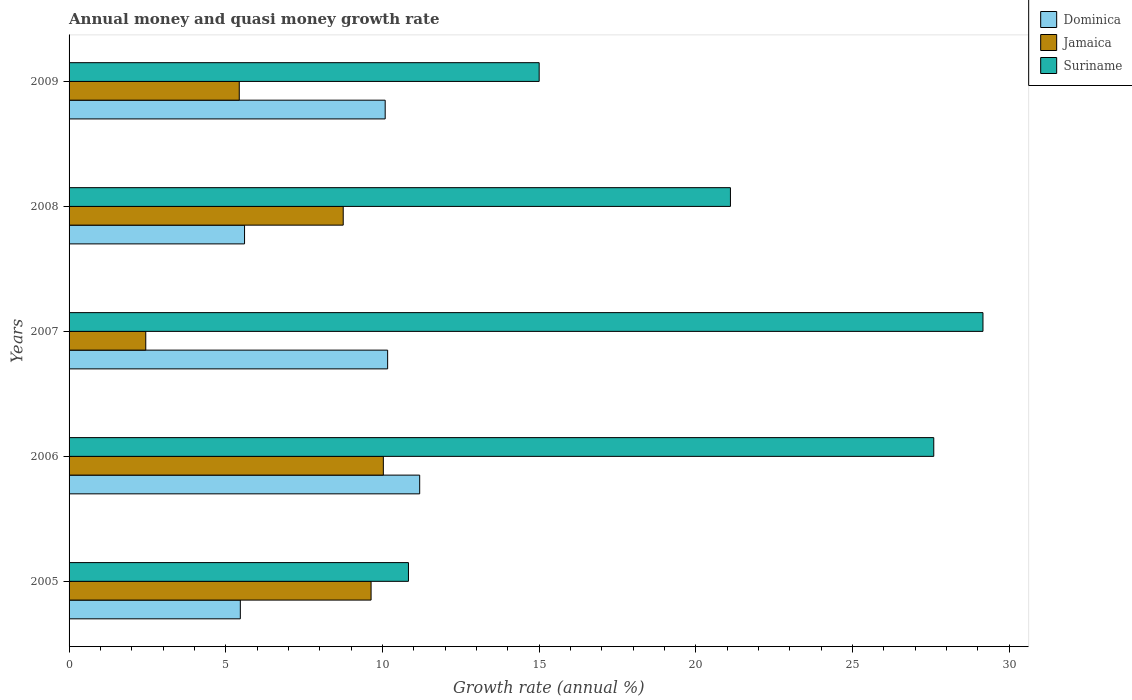How many bars are there on the 2nd tick from the bottom?
Offer a very short reply. 3. What is the growth rate in Dominica in 2008?
Ensure brevity in your answer.  5.6. Across all years, what is the maximum growth rate in Jamaica?
Make the answer very short. 10.03. Across all years, what is the minimum growth rate in Jamaica?
Offer a terse response. 2.45. In which year was the growth rate in Jamaica minimum?
Keep it short and to the point. 2007. What is the total growth rate in Jamaica in the graph?
Your response must be concise. 36.3. What is the difference between the growth rate in Dominica in 2007 and that in 2008?
Offer a terse response. 4.57. What is the difference between the growth rate in Jamaica in 2005 and the growth rate in Dominica in 2008?
Give a very brief answer. 4.04. What is the average growth rate in Jamaica per year?
Give a very brief answer. 7.26. In the year 2006, what is the difference between the growth rate in Jamaica and growth rate in Suriname?
Your response must be concise. -17.57. What is the ratio of the growth rate in Jamaica in 2007 to that in 2009?
Your answer should be very brief. 0.45. Is the difference between the growth rate in Jamaica in 2005 and 2008 greater than the difference between the growth rate in Suriname in 2005 and 2008?
Your response must be concise. Yes. What is the difference between the highest and the second highest growth rate in Dominica?
Offer a very short reply. 1.02. What is the difference between the highest and the lowest growth rate in Jamaica?
Offer a terse response. 7.58. In how many years, is the growth rate in Suriname greater than the average growth rate in Suriname taken over all years?
Offer a terse response. 3. What does the 1st bar from the top in 2005 represents?
Your answer should be compact. Suriname. What does the 2nd bar from the bottom in 2006 represents?
Offer a terse response. Jamaica. How many bars are there?
Your answer should be compact. 15. Are all the bars in the graph horizontal?
Offer a very short reply. Yes. How many years are there in the graph?
Keep it short and to the point. 5. What is the difference between two consecutive major ticks on the X-axis?
Offer a very short reply. 5. Does the graph contain grids?
Your answer should be very brief. No. Where does the legend appear in the graph?
Ensure brevity in your answer.  Top right. What is the title of the graph?
Make the answer very short. Annual money and quasi money growth rate. What is the label or title of the X-axis?
Ensure brevity in your answer.  Growth rate (annual %). What is the label or title of the Y-axis?
Ensure brevity in your answer.  Years. What is the Growth rate (annual %) of Dominica in 2005?
Offer a very short reply. 5.47. What is the Growth rate (annual %) of Jamaica in 2005?
Offer a terse response. 9.64. What is the Growth rate (annual %) of Suriname in 2005?
Your response must be concise. 10.83. What is the Growth rate (annual %) in Dominica in 2006?
Keep it short and to the point. 11.19. What is the Growth rate (annual %) of Jamaica in 2006?
Provide a short and direct response. 10.03. What is the Growth rate (annual %) in Suriname in 2006?
Keep it short and to the point. 27.6. What is the Growth rate (annual %) in Dominica in 2007?
Provide a succinct answer. 10.17. What is the Growth rate (annual %) in Jamaica in 2007?
Your answer should be very brief. 2.45. What is the Growth rate (annual %) in Suriname in 2007?
Make the answer very short. 29.17. What is the Growth rate (annual %) in Dominica in 2008?
Your response must be concise. 5.6. What is the Growth rate (annual %) in Jamaica in 2008?
Offer a very short reply. 8.75. What is the Growth rate (annual %) in Suriname in 2008?
Provide a short and direct response. 21.11. What is the Growth rate (annual %) of Dominica in 2009?
Make the answer very short. 10.09. What is the Growth rate (annual %) in Jamaica in 2009?
Provide a short and direct response. 5.43. What is the Growth rate (annual %) of Suriname in 2009?
Offer a terse response. 15. Across all years, what is the maximum Growth rate (annual %) in Dominica?
Provide a succinct answer. 11.19. Across all years, what is the maximum Growth rate (annual %) of Jamaica?
Your answer should be compact. 10.03. Across all years, what is the maximum Growth rate (annual %) in Suriname?
Offer a very short reply. 29.17. Across all years, what is the minimum Growth rate (annual %) in Dominica?
Keep it short and to the point. 5.47. Across all years, what is the minimum Growth rate (annual %) in Jamaica?
Make the answer very short. 2.45. Across all years, what is the minimum Growth rate (annual %) in Suriname?
Provide a short and direct response. 10.83. What is the total Growth rate (annual %) in Dominica in the graph?
Give a very brief answer. 42.51. What is the total Growth rate (annual %) in Jamaica in the graph?
Offer a very short reply. 36.3. What is the total Growth rate (annual %) in Suriname in the graph?
Your answer should be very brief. 103.7. What is the difference between the Growth rate (annual %) in Dominica in 2005 and that in 2006?
Provide a succinct answer. -5.72. What is the difference between the Growth rate (annual %) of Jamaica in 2005 and that in 2006?
Give a very brief answer. -0.39. What is the difference between the Growth rate (annual %) of Suriname in 2005 and that in 2006?
Keep it short and to the point. -16.76. What is the difference between the Growth rate (annual %) of Dominica in 2005 and that in 2007?
Offer a very short reply. -4.7. What is the difference between the Growth rate (annual %) of Jamaica in 2005 and that in 2007?
Your answer should be very brief. 7.19. What is the difference between the Growth rate (annual %) of Suriname in 2005 and that in 2007?
Your response must be concise. -18.34. What is the difference between the Growth rate (annual %) in Dominica in 2005 and that in 2008?
Provide a succinct answer. -0.13. What is the difference between the Growth rate (annual %) of Jamaica in 2005 and that in 2008?
Your response must be concise. 0.89. What is the difference between the Growth rate (annual %) in Suriname in 2005 and that in 2008?
Give a very brief answer. -10.28. What is the difference between the Growth rate (annual %) of Dominica in 2005 and that in 2009?
Your answer should be compact. -4.62. What is the difference between the Growth rate (annual %) in Jamaica in 2005 and that in 2009?
Offer a terse response. 4.21. What is the difference between the Growth rate (annual %) of Suriname in 2005 and that in 2009?
Your answer should be very brief. -4.17. What is the difference between the Growth rate (annual %) in Dominica in 2006 and that in 2007?
Provide a short and direct response. 1.02. What is the difference between the Growth rate (annual %) of Jamaica in 2006 and that in 2007?
Offer a very short reply. 7.58. What is the difference between the Growth rate (annual %) in Suriname in 2006 and that in 2007?
Make the answer very short. -1.57. What is the difference between the Growth rate (annual %) in Dominica in 2006 and that in 2008?
Offer a very short reply. 5.59. What is the difference between the Growth rate (annual %) of Jamaica in 2006 and that in 2008?
Provide a succinct answer. 1.28. What is the difference between the Growth rate (annual %) of Suriname in 2006 and that in 2008?
Make the answer very short. 6.49. What is the difference between the Growth rate (annual %) of Dominica in 2006 and that in 2009?
Ensure brevity in your answer.  1.1. What is the difference between the Growth rate (annual %) in Jamaica in 2006 and that in 2009?
Provide a succinct answer. 4.6. What is the difference between the Growth rate (annual %) of Suriname in 2006 and that in 2009?
Offer a very short reply. 12.59. What is the difference between the Growth rate (annual %) of Dominica in 2007 and that in 2008?
Your answer should be compact. 4.57. What is the difference between the Growth rate (annual %) in Jamaica in 2007 and that in 2008?
Offer a terse response. -6.3. What is the difference between the Growth rate (annual %) in Suriname in 2007 and that in 2008?
Offer a terse response. 8.06. What is the difference between the Growth rate (annual %) of Dominica in 2007 and that in 2009?
Provide a short and direct response. 0.08. What is the difference between the Growth rate (annual %) of Jamaica in 2007 and that in 2009?
Ensure brevity in your answer.  -2.98. What is the difference between the Growth rate (annual %) in Suriname in 2007 and that in 2009?
Make the answer very short. 14.16. What is the difference between the Growth rate (annual %) in Dominica in 2008 and that in 2009?
Your answer should be very brief. -4.49. What is the difference between the Growth rate (annual %) of Jamaica in 2008 and that in 2009?
Provide a succinct answer. 3.32. What is the difference between the Growth rate (annual %) in Suriname in 2008 and that in 2009?
Keep it short and to the point. 6.1. What is the difference between the Growth rate (annual %) in Dominica in 2005 and the Growth rate (annual %) in Jamaica in 2006?
Make the answer very short. -4.56. What is the difference between the Growth rate (annual %) of Dominica in 2005 and the Growth rate (annual %) of Suriname in 2006?
Your answer should be very brief. -22.13. What is the difference between the Growth rate (annual %) of Jamaica in 2005 and the Growth rate (annual %) of Suriname in 2006?
Provide a short and direct response. -17.96. What is the difference between the Growth rate (annual %) of Dominica in 2005 and the Growth rate (annual %) of Jamaica in 2007?
Ensure brevity in your answer.  3.02. What is the difference between the Growth rate (annual %) of Dominica in 2005 and the Growth rate (annual %) of Suriname in 2007?
Your answer should be very brief. -23.7. What is the difference between the Growth rate (annual %) in Jamaica in 2005 and the Growth rate (annual %) in Suriname in 2007?
Your response must be concise. -19.53. What is the difference between the Growth rate (annual %) in Dominica in 2005 and the Growth rate (annual %) in Jamaica in 2008?
Make the answer very short. -3.28. What is the difference between the Growth rate (annual %) in Dominica in 2005 and the Growth rate (annual %) in Suriname in 2008?
Make the answer very short. -15.64. What is the difference between the Growth rate (annual %) of Jamaica in 2005 and the Growth rate (annual %) of Suriname in 2008?
Make the answer very short. -11.47. What is the difference between the Growth rate (annual %) in Dominica in 2005 and the Growth rate (annual %) in Jamaica in 2009?
Offer a terse response. 0.03. What is the difference between the Growth rate (annual %) of Dominica in 2005 and the Growth rate (annual %) of Suriname in 2009?
Offer a very short reply. -9.54. What is the difference between the Growth rate (annual %) of Jamaica in 2005 and the Growth rate (annual %) of Suriname in 2009?
Your answer should be very brief. -5.36. What is the difference between the Growth rate (annual %) in Dominica in 2006 and the Growth rate (annual %) in Jamaica in 2007?
Provide a succinct answer. 8.74. What is the difference between the Growth rate (annual %) in Dominica in 2006 and the Growth rate (annual %) in Suriname in 2007?
Your answer should be compact. -17.98. What is the difference between the Growth rate (annual %) in Jamaica in 2006 and the Growth rate (annual %) in Suriname in 2007?
Make the answer very short. -19.14. What is the difference between the Growth rate (annual %) of Dominica in 2006 and the Growth rate (annual %) of Jamaica in 2008?
Provide a succinct answer. 2.44. What is the difference between the Growth rate (annual %) of Dominica in 2006 and the Growth rate (annual %) of Suriname in 2008?
Your answer should be compact. -9.92. What is the difference between the Growth rate (annual %) of Jamaica in 2006 and the Growth rate (annual %) of Suriname in 2008?
Offer a terse response. -11.08. What is the difference between the Growth rate (annual %) of Dominica in 2006 and the Growth rate (annual %) of Jamaica in 2009?
Your answer should be very brief. 5.76. What is the difference between the Growth rate (annual %) in Dominica in 2006 and the Growth rate (annual %) in Suriname in 2009?
Provide a succinct answer. -3.81. What is the difference between the Growth rate (annual %) in Jamaica in 2006 and the Growth rate (annual %) in Suriname in 2009?
Your response must be concise. -4.97. What is the difference between the Growth rate (annual %) of Dominica in 2007 and the Growth rate (annual %) of Jamaica in 2008?
Make the answer very short. 1.42. What is the difference between the Growth rate (annual %) of Dominica in 2007 and the Growth rate (annual %) of Suriname in 2008?
Offer a terse response. -10.94. What is the difference between the Growth rate (annual %) of Jamaica in 2007 and the Growth rate (annual %) of Suriname in 2008?
Give a very brief answer. -18.66. What is the difference between the Growth rate (annual %) of Dominica in 2007 and the Growth rate (annual %) of Jamaica in 2009?
Offer a very short reply. 4.74. What is the difference between the Growth rate (annual %) in Dominica in 2007 and the Growth rate (annual %) in Suriname in 2009?
Offer a very short reply. -4.84. What is the difference between the Growth rate (annual %) in Jamaica in 2007 and the Growth rate (annual %) in Suriname in 2009?
Your answer should be very brief. -12.56. What is the difference between the Growth rate (annual %) in Dominica in 2008 and the Growth rate (annual %) in Jamaica in 2009?
Provide a short and direct response. 0.17. What is the difference between the Growth rate (annual %) in Dominica in 2008 and the Growth rate (annual %) in Suriname in 2009?
Make the answer very short. -9.4. What is the difference between the Growth rate (annual %) in Jamaica in 2008 and the Growth rate (annual %) in Suriname in 2009?
Your answer should be compact. -6.25. What is the average Growth rate (annual %) in Dominica per year?
Ensure brevity in your answer.  8.5. What is the average Growth rate (annual %) in Jamaica per year?
Make the answer very short. 7.26. What is the average Growth rate (annual %) of Suriname per year?
Offer a very short reply. 20.74. In the year 2005, what is the difference between the Growth rate (annual %) of Dominica and Growth rate (annual %) of Jamaica?
Ensure brevity in your answer.  -4.17. In the year 2005, what is the difference between the Growth rate (annual %) in Dominica and Growth rate (annual %) in Suriname?
Offer a very short reply. -5.37. In the year 2005, what is the difference between the Growth rate (annual %) of Jamaica and Growth rate (annual %) of Suriname?
Your answer should be very brief. -1.19. In the year 2006, what is the difference between the Growth rate (annual %) in Dominica and Growth rate (annual %) in Jamaica?
Your response must be concise. 1.16. In the year 2006, what is the difference between the Growth rate (annual %) in Dominica and Growth rate (annual %) in Suriname?
Your answer should be very brief. -16.41. In the year 2006, what is the difference between the Growth rate (annual %) of Jamaica and Growth rate (annual %) of Suriname?
Give a very brief answer. -17.57. In the year 2007, what is the difference between the Growth rate (annual %) in Dominica and Growth rate (annual %) in Jamaica?
Your answer should be very brief. 7.72. In the year 2007, what is the difference between the Growth rate (annual %) of Dominica and Growth rate (annual %) of Suriname?
Give a very brief answer. -19. In the year 2007, what is the difference between the Growth rate (annual %) of Jamaica and Growth rate (annual %) of Suriname?
Provide a succinct answer. -26.72. In the year 2008, what is the difference between the Growth rate (annual %) of Dominica and Growth rate (annual %) of Jamaica?
Keep it short and to the point. -3.15. In the year 2008, what is the difference between the Growth rate (annual %) in Dominica and Growth rate (annual %) in Suriname?
Provide a succinct answer. -15.51. In the year 2008, what is the difference between the Growth rate (annual %) of Jamaica and Growth rate (annual %) of Suriname?
Provide a succinct answer. -12.36. In the year 2009, what is the difference between the Growth rate (annual %) in Dominica and Growth rate (annual %) in Jamaica?
Ensure brevity in your answer.  4.66. In the year 2009, what is the difference between the Growth rate (annual %) of Dominica and Growth rate (annual %) of Suriname?
Offer a very short reply. -4.91. In the year 2009, what is the difference between the Growth rate (annual %) of Jamaica and Growth rate (annual %) of Suriname?
Your response must be concise. -9.57. What is the ratio of the Growth rate (annual %) of Dominica in 2005 to that in 2006?
Give a very brief answer. 0.49. What is the ratio of the Growth rate (annual %) in Jamaica in 2005 to that in 2006?
Offer a terse response. 0.96. What is the ratio of the Growth rate (annual %) of Suriname in 2005 to that in 2006?
Ensure brevity in your answer.  0.39. What is the ratio of the Growth rate (annual %) of Dominica in 2005 to that in 2007?
Your answer should be compact. 0.54. What is the ratio of the Growth rate (annual %) in Jamaica in 2005 to that in 2007?
Offer a terse response. 3.94. What is the ratio of the Growth rate (annual %) of Suriname in 2005 to that in 2007?
Give a very brief answer. 0.37. What is the ratio of the Growth rate (annual %) of Dominica in 2005 to that in 2008?
Your answer should be compact. 0.98. What is the ratio of the Growth rate (annual %) in Jamaica in 2005 to that in 2008?
Make the answer very short. 1.1. What is the ratio of the Growth rate (annual %) of Suriname in 2005 to that in 2008?
Provide a short and direct response. 0.51. What is the ratio of the Growth rate (annual %) of Dominica in 2005 to that in 2009?
Provide a succinct answer. 0.54. What is the ratio of the Growth rate (annual %) in Jamaica in 2005 to that in 2009?
Your response must be concise. 1.77. What is the ratio of the Growth rate (annual %) in Suriname in 2005 to that in 2009?
Your answer should be compact. 0.72. What is the ratio of the Growth rate (annual %) in Dominica in 2006 to that in 2007?
Keep it short and to the point. 1.1. What is the ratio of the Growth rate (annual %) in Jamaica in 2006 to that in 2007?
Provide a succinct answer. 4.1. What is the ratio of the Growth rate (annual %) in Suriname in 2006 to that in 2007?
Keep it short and to the point. 0.95. What is the ratio of the Growth rate (annual %) of Dominica in 2006 to that in 2008?
Make the answer very short. 2. What is the ratio of the Growth rate (annual %) of Jamaica in 2006 to that in 2008?
Your response must be concise. 1.15. What is the ratio of the Growth rate (annual %) of Suriname in 2006 to that in 2008?
Provide a short and direct response. 1.31. What is the ratio of the Growth rate (annual %) in Dominica in 2006 to that in 2009?
Give a very brief answer. 1.11. What is the ratio of the Growth rate (annual %) in Jamaica in 2006 to that in 2009?
Provide a succinct answer. 1.85. What is the ratio of the Growth rate (annual %) of Suriname in 2006 to that in 2009?
Provide a succinct answer. 1.84. What is the ratio of the Growth rate (annual %) of Dominica in 2007 to that in 2008?
Make the answer very short. 1.82. What is the ratio of the Growth rate (annual %) in Jamaica in 2007 to that in 2008?
Your response must be concise. 0.28. What is the ratio of the Growth rate (annual %) in Suriname in 2007 to that in 2008?
Keep it short and to the point. 1.38. What is the ratio of the Growth rate (annual %) of Dominica in 2007 to that in 2009?
Your answer should be compact. 1.01. What is the ratio of the Growth rate (annual %) of Jamaica in 2007 to that in 2009?
Offer a terse response. 0.45. What is the ratio of the Growth rate (annual %) of Suriname in 2007 to that in 2009?
Offer a very short reply. 1.94. What is the ratio of the Growth rate (annual %) of Dominica in 2008 to that in 2009?
Make the answer very short. 0.56. What is the ratio of the Growth rate (annual %) of Jamaica in 2008 to that in 2009?
Make the answer very short. 1.61. What is the ratio of the Growth rate (annual %) of Suriname in 2008 to that in 2009?
Your response must be concise. 1.41. What is the difference between the highest and the second highest Growth rate (annual %) of Dominica?
Give a very brief answer. 1.02. What is the difference between the highest and the second highest Growth rate (annual %) in Jamaica?
Offer a very short reply. 0.39. What is the difference between the highest and the second highest Growth rate (annual %) of Suriname?
Offer a terse response. 1.57. What is the difference between the highest and the lowest Growth rate (annual %) of Dominica?
Your answer should be compact. 5.72. What is the difference between the highest and the lowest Growth rate (annual %) of Jamaica?
Offer a terse response. 7.58. What is the difference between the highest and the lowest Growth rate (annual %) of Suriname?
Offer a very short reply. 18.34. 